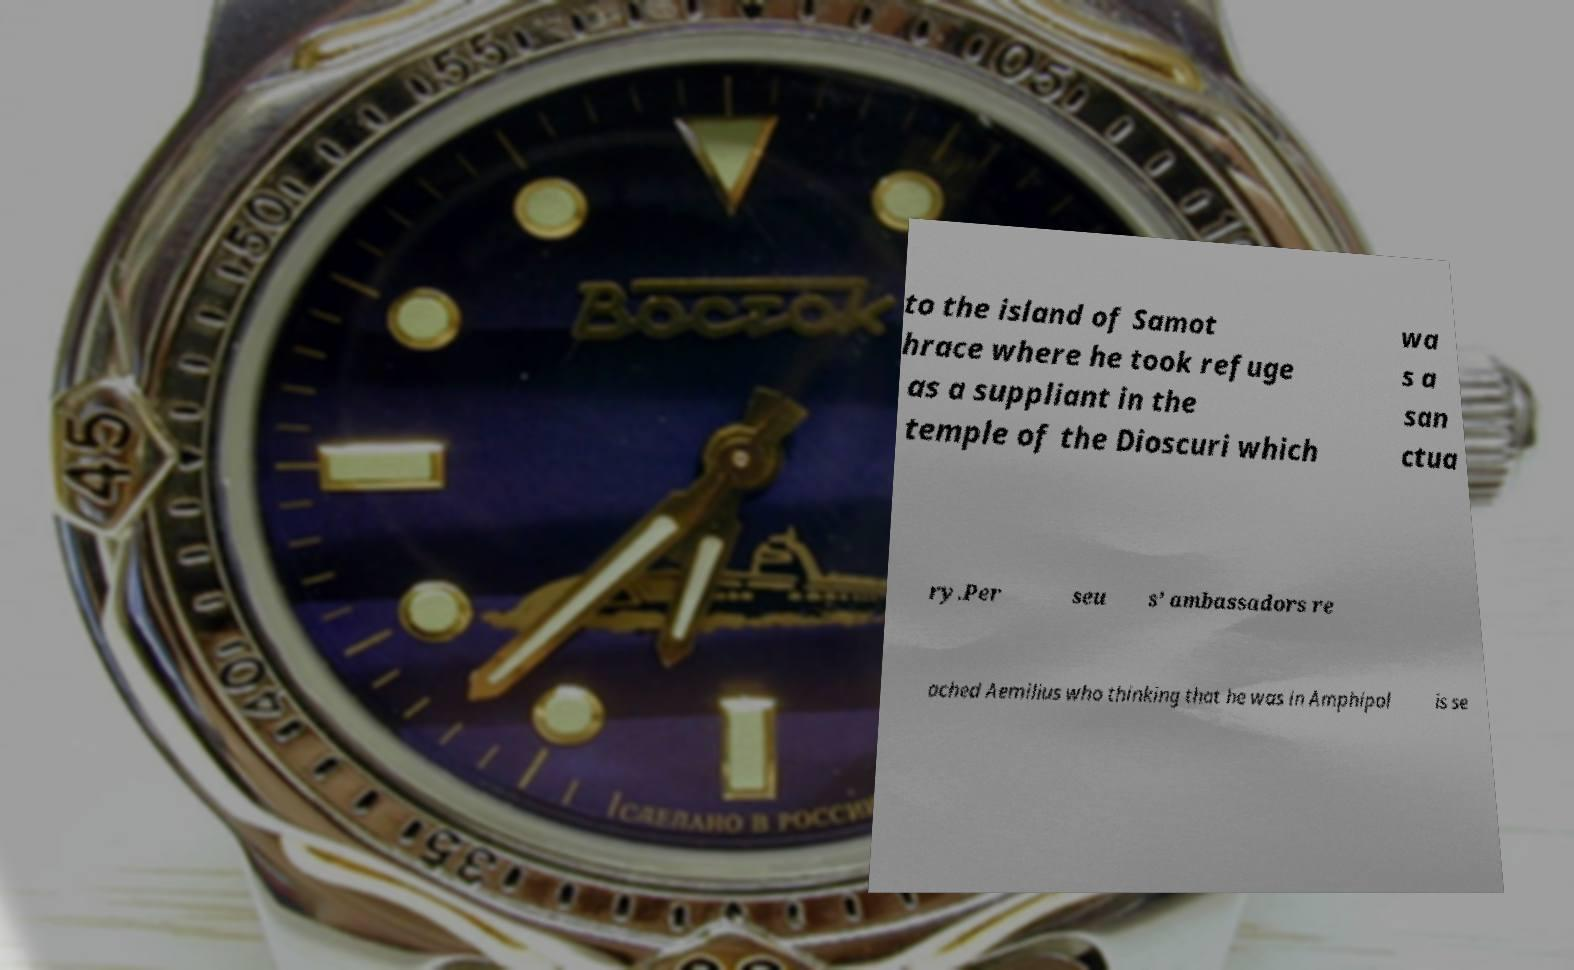Can you accurately transcribe the text from the provided image for me? to the island of Samot hrace where he took refuge as a suppliant in the temple of the Dioscuri which wa s a san ctua ry.Per seu s’ ambassadors re ached Aemilius who thinking that he was in Amphipol is se 